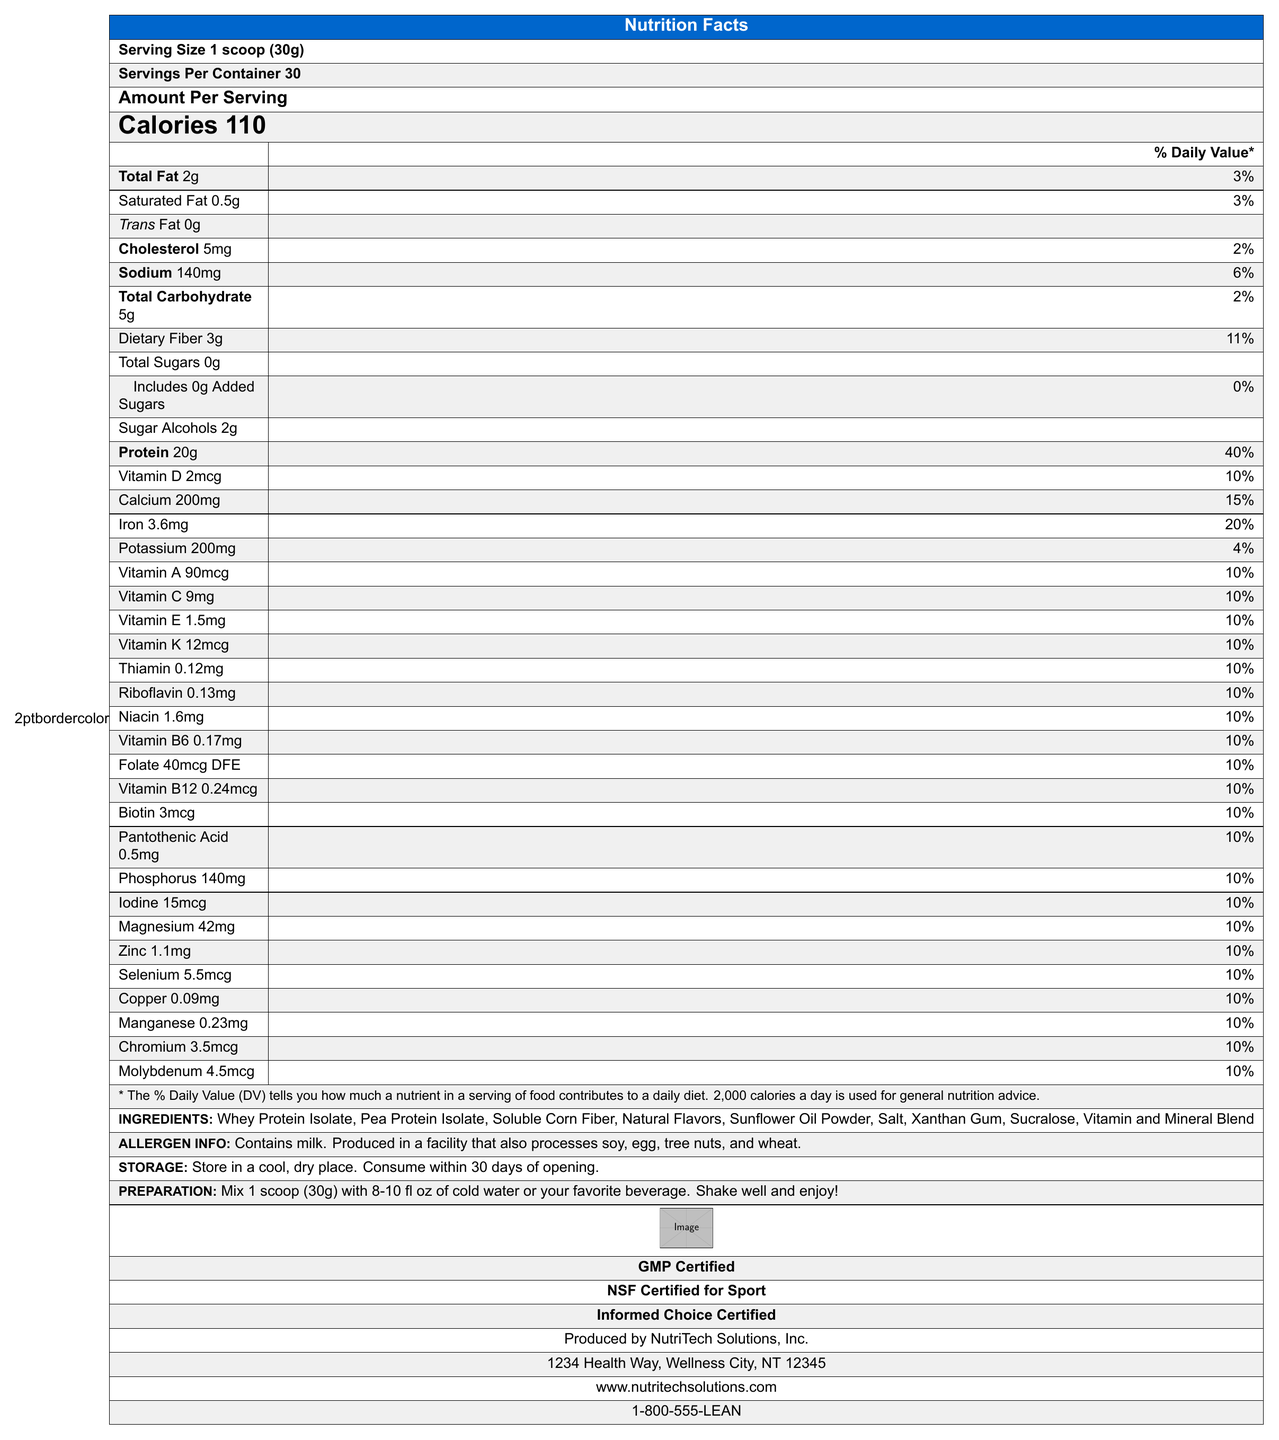what is the serving size? The serving size is listed as "Serving Size 1 scoop (30g)" at the beginning of the document.
Answer: 1 scoop (30g) how many calories are in one serving? The document specifies "Calories 110" under the "Amount Per Serving" section.
Answer: 110 what is the amount of protein per serving? The table includes "Protein 20g" next to its daily value percentage.
Answer: 20g how many servings are there per container? At the beginning of the document, it states "Servings Per Container 30".
Answer: 30 what are the amounts of total fat and sodium per serving? The document specifies "Total Fat 2g" and "Sodium 140mg" in the nutritional breakdown.
Answer: 2g of total fat and 140mg of sodium is the product sugar-free? The document shows "Total Sugars 0g" and "Includes 0g Added Sugars", indicating no sugar is present.
Answer: Yes what are the vitamins listed in the document? The document lists these vitamins along with their amounts and daily values.
Answer: Vitamins D, A, C, E, K, Thiamin, Riboflavin, Niacin, B6, Folate, B12, Biotin, Pantothenic Acid how much dietary fiber does each serving contain? The document includes "Dietary Fiber 3g" in the nutritional information.
Answer: 3g which certification does this product have? A. USDA Organic B. GMP Certified C. Fair Trade The document states "GMP Certified" along with other certifications, but not "USDA Organic" or "Fair Trade".
Answer: B how much iron is contained per serving? A. 2.5mg B. 3.6mg C. 1.8mg The document lists "Iron 3.6mg" under the nutritional information.
Answer: B does the product contain any allergens? The document notes "Contains milk. Produced in a facility that also processes soy, egg, tree nuts, and wheat."
Answer: Yes what type of product is this document describing? The document title is "VitaLean Meal Replacement Shake" indicating it is a meal replacement shake.
Answer: A meal replacement shake is this product good for someone who needs to avoid gluten? The document notes allergens but does not specify if the product is gluten-free.
Answer: Cannot be determined who produces this product? The document specifies "Produced by NutriTech Solutions, Inc." at the bottom.
Answer: NutriTech Solutions, Inc. where is the product manufactured? The document provides this address under the manufacturing information.
Answer: 1234 Health Way, Wellness City, NT 12345 how should the product be stored? The document underlines the storage instructions towards the end.
Answer: Store in a cool, dry place and consume within 30 days of opening describe the main components of this Nutrition Facts document This explanation covers the structured data points and additional information such as storage, preparation, and certifications to give a full overview of the product’s nutritional facts panel.
Answer: The document details the serving size, servings per container, caloric content, amounts of macronutrients such as fats, carbohydrates, and proteins, a list of vitamins and minerals with their respective daily values, ingredient list, allergen information, storage and preparation instructions, certifications, and manufacturer details. 